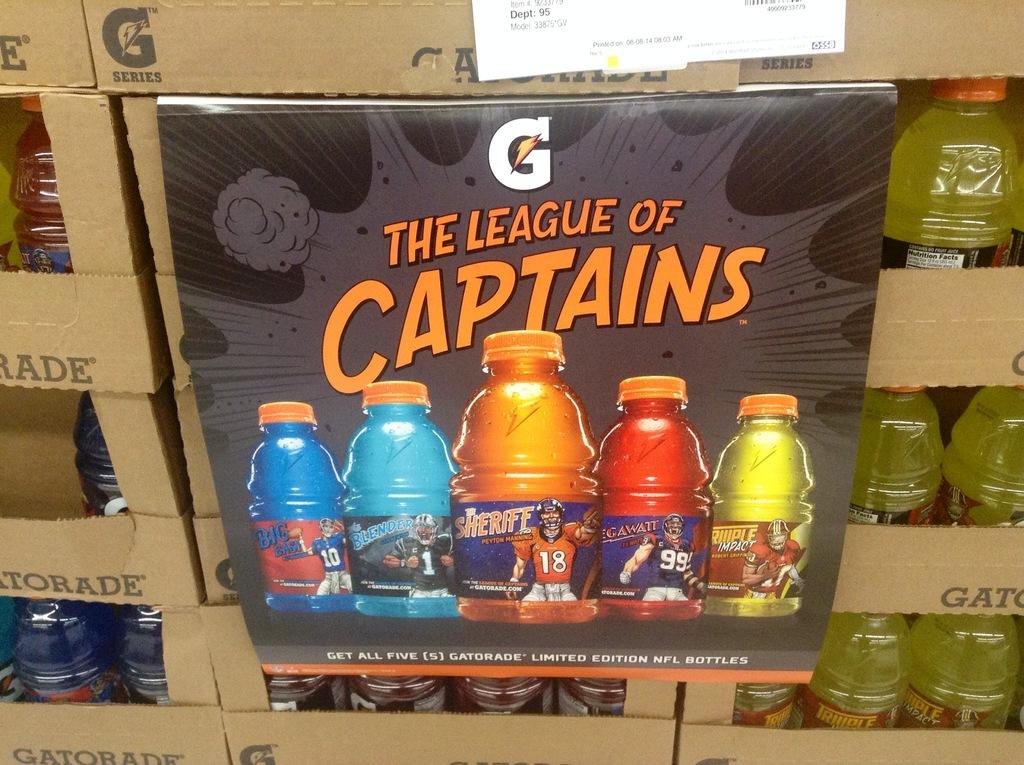What is the main object in the center of the image? There is a sign board in the center of the image. What can be seen in the background of the image? There are boxes with water bottles in the background of the image. What does the sister say about the advertisement on the sign board in the image? There is no sister present in the image, nor is there any advertisement mentioned in the provided facts. 